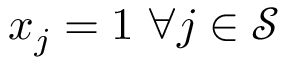Convert formula to latex. <formula><loc_0><loc_0><loc_500><loc_500>x _ { j } = 1 \, \forall j \in \mathcal { S }</formula> 